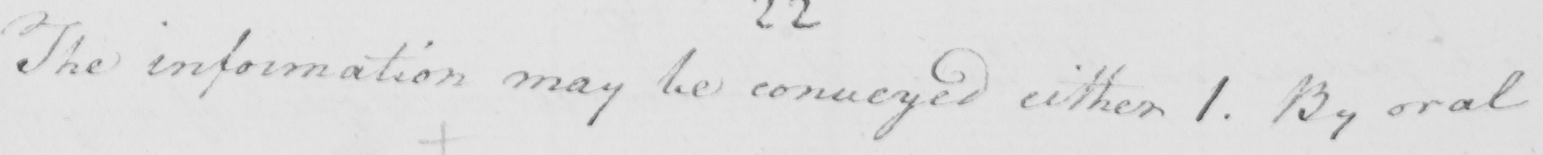Please provide the text content of this handwritten line. The information may be conveyed either 1 . By oral 